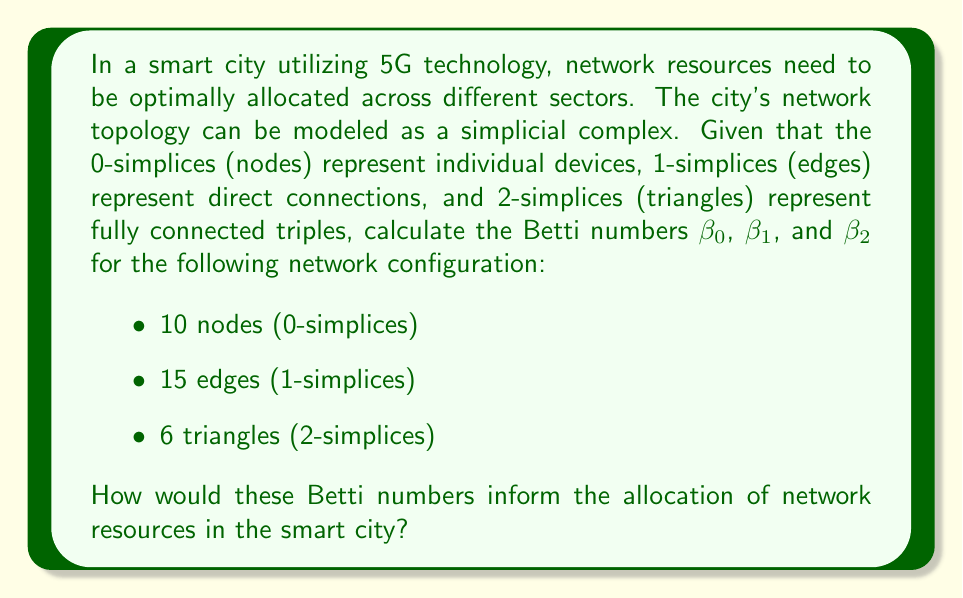Show me your answer to this math problem. To solve this problem, we'll use the concepts from algebraic topology, specifically the calculation of Betti numbers for a simplicial complex. Let's approach this step-by-step:

1) First, let's recall what Betti numbers represent:
   - $\beta_0$: number of connected components
   - $\beta_1$: number of 1-dimensional holes (loops)
   - $\beta_2$: number of 2-dimensional voids (cavities)

2) To calculate the Betti numbers, we'll use the formula:
   $$\beta_i = \text{rank}(Z_i) - \text{rank}(B_i)$$
   where $Z_i$ is the group of i-cycles and $B_i$ is the group of i-boundaries.

3) For $\beta_0$:
   - In a connected network, $\beta_0 = 1$. We'll assume the network is connected as it's a smart city network.

4) For $\beta_1$:
   - We can use the Euler characteristic formula: $\chi = V - E + F$
   - Where V is the number of vertices, E is the number of edges, and F is the number of faces (triangles in this case)
   - $\chi = 10 - 15 + 6 = 1$
   - We also know that $\chi = \beta_0 - \beta_1 + \beta_2$
   - Substituting: $1 = 1 - \beta_1 + \beta_2$
   - So, $\beta_1 = \beta_2$

5) For $\beta_2$:
   - In a simplicial complex, $\beta_2$ represents the number of 3D voids
   - Given we only have up to 2-simplices (triangles), there are no 3D voids
   - Therefore, $\beta_2 = 0$

6) From step 4 and 5, we can conclude that $\beta_1 = 0$ as well.

Therefore, the Betti numbers are:
$\beta_0 = 1$, $\beta_1 = 0$, $\beta_2 = 0$

These Betti numbers inform resource allocation in the following ways:

- $\beta_0 = 1$ indicates a single connected component, suggesting that all devices in the network can communicate with each other, either directly or indirectly. This implies that resources can be shared across the entire network.

- $\beta_1 = 0$ indicates no 1-dimensional holes, meaning there are no redundant paths in the network. This suggests that the network is efficient in terms of connectivity but may lack alternative routes for load balancing or fault tolerance.

- $\beta_2 = 0$ indicates no 2-dimensional voids, suggesting that the network has a flat structure without any enclosed empty spaces. This could imply that the network coverage is comprehensive within its scope.

For optimal resource allocation, the network administrator might consider:
1) Maintaining the single connected component ($\beta_0 = 1$) for unified resource management.
2) Potentially adding some redundant connections to increase $\beta_1$, improving network resilience and load balancing capabilities.
3) Ensuring that the flat structure ($\beta_2 = 0$) doesn't lead to bottlenecks, and considering if any hierarchical elements could improve efficiency.
Answer: $\beta_0 = 1$, $\beta_1 = 0$, $\beta_2 = 0$. These indicate a single connected network with no redundant paths or voids, suggesting efficient but potentially vulnerable connectivity. 